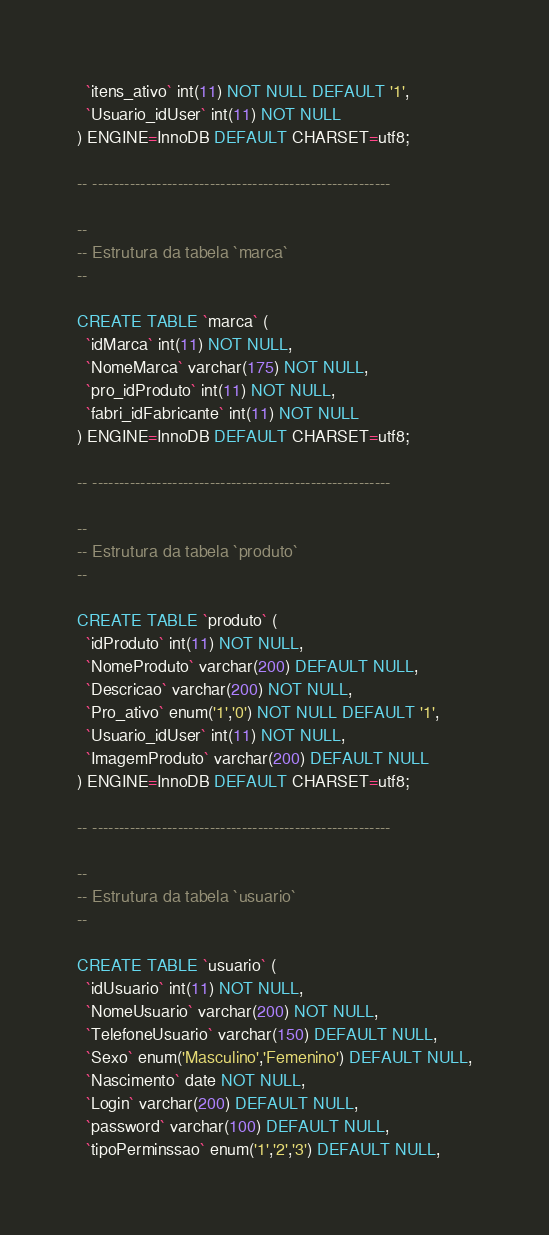<code> <loc_0><loc_0><loc_500><loc_500><_SQL_>  `itens_ativo` int(11) NOT NULL DEFAULT '1',
  `Usuario_idUser` int(11) NOT NULL
) ENGINE=InnoDB DEFAULT CHARSET=utf8;

-- --------------------------------------------------------

--
-- Estrutura da tabela `marca`
--

CREATE TABLE `marca` (
  `idMarca` int(11) NOT NULL,
  `NomeMarca` varchar(175) NOT NULL,
  `pro_idProduto` int(11) NOT NULL,
  `fabri_idFabricante` int(11) NOT NULL
) ENGINE=InnoDB DEFAULT CHARSET=utf8;

-- --------------------------------------------------------

--
-- Estrutura da tabela `produto`
--

CREATE TABLE `produto` (
  `idProduto` int(11) NOT NULL,
  `NomeProduto` varchar(200) DEFAULT NULL,
  `Descricao` varchar(200) NOT NULL,
  `Pro_ativo` enum('1','0') NOT NULL DEFAULT '1',
  `Usuario_idUser` int(11) NOT NULL,
  `ImagemProduto` varchar(200) DEFAULT NULL
) ENGINE=InnoDB DEFAULT CHARSET=utf8;

-- --------------------------------------------------------

--
-- Estrutura da tabela `usuario`
--

CREATE TABLE `usuario` (
  `idUsuario` int(11) NOT NULL,
  `NomeUsuario` varchar(200) NOT NULL,
  `TelefoneUsuario` varchar(150) DEFAULT NULL,
  `Sexo` enum('Masculino','Femenino') DEFAULT NULL,
  `Nascimento` date NOT NULL,
  `Login` varchar(200) DEFAULT NULL,
  `password` varchar(100) DEFAULT NULL,
  `tipoPerminssao` enum('1','2','3') DEFAULT NULL,</code> 